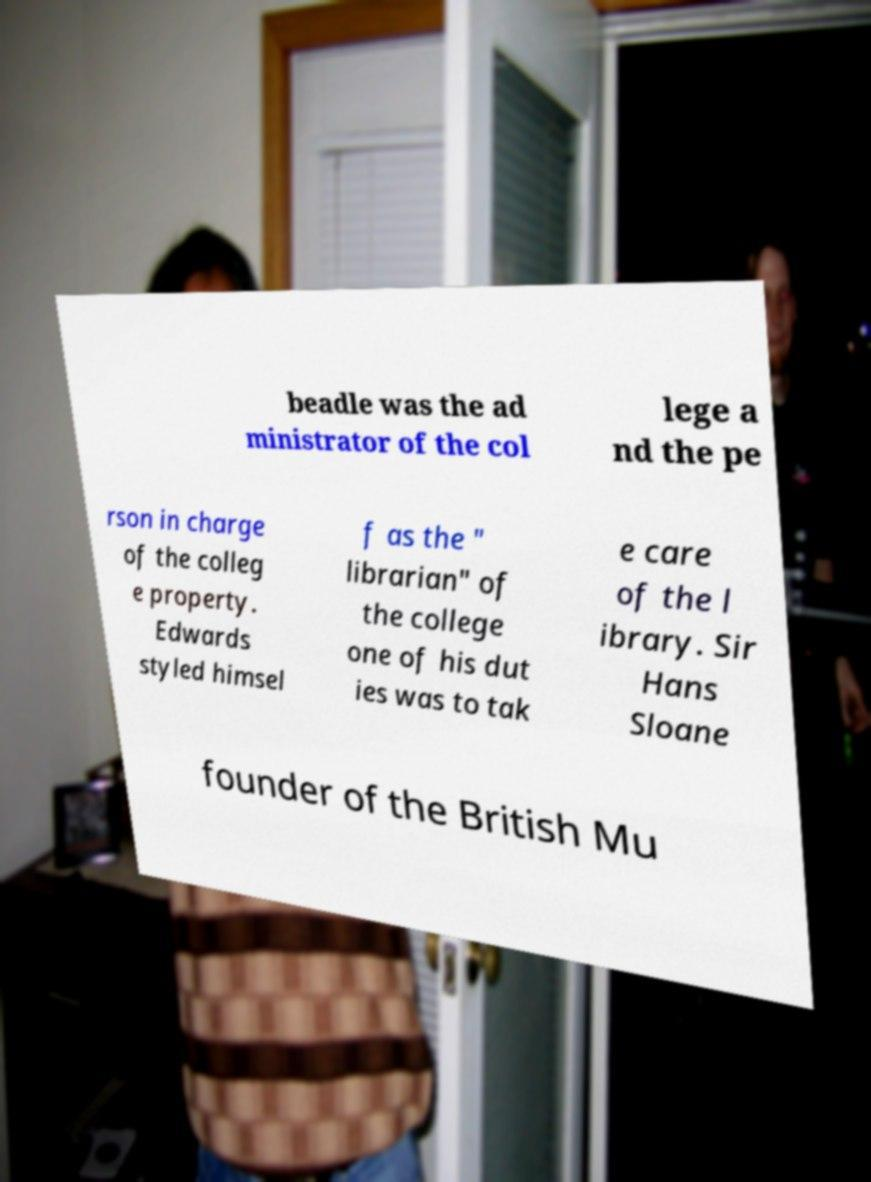Could you extract and type out the text from this image? beadle was the ad ministrator of the col lege a nd the pe rson in charge of the colleg e property. Edwards styled himsel f as the " librarian" of the college one of his dut ies was to tak e care of the l ibrary. Sir Hans Sloane founder of the British Mu 